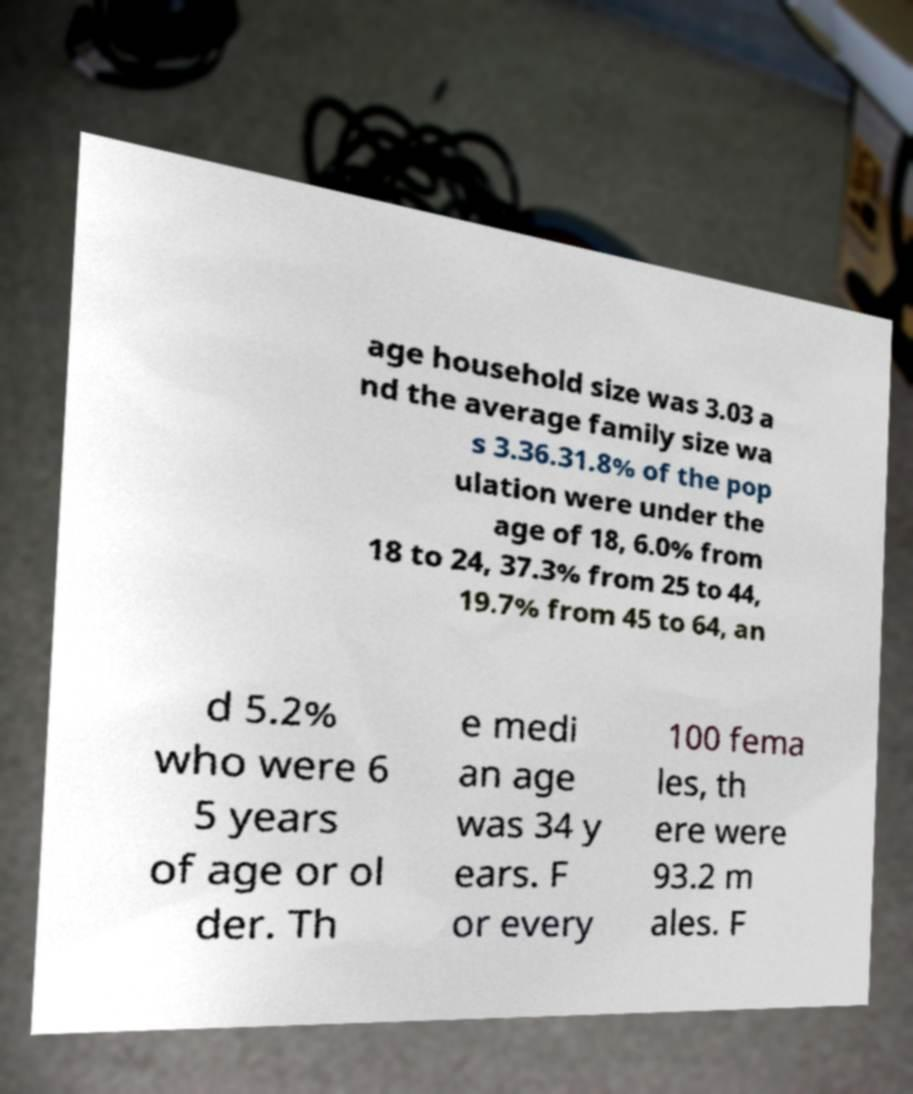For documentation purposes, I need the text within this image transcribed. Could you provide that? age household size was 3.03 a nd the average family size wa s 3.36.31.8% of the pop ulation were under the age of 18, 6.0% from 18 to 24, 37.3% from 25 to 44, 19.7% from 45 to 64, an d 5.2% who were 6 5 years of age or ol der. Th e medi an age was 34 y ears. F or every 100 fema les, th ere were 93.2 m ales. F 